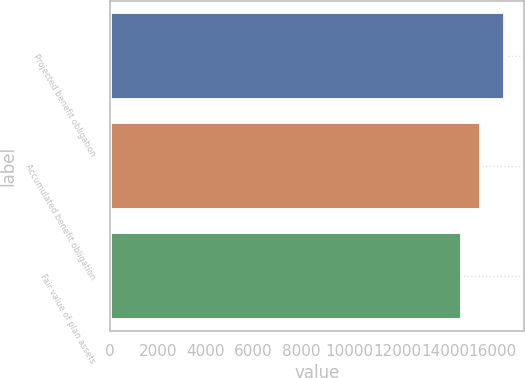Convert chart. <chart><loc_0><loc_0><loc_500><loc_500><bar_chart><fcel>Projected benefit obligation<fcel>Accumulated benefit obligation<fcel>Fair value of plan assets<nl><fcel>16492<fcel>15496<fcel>14703<nl></chart> 